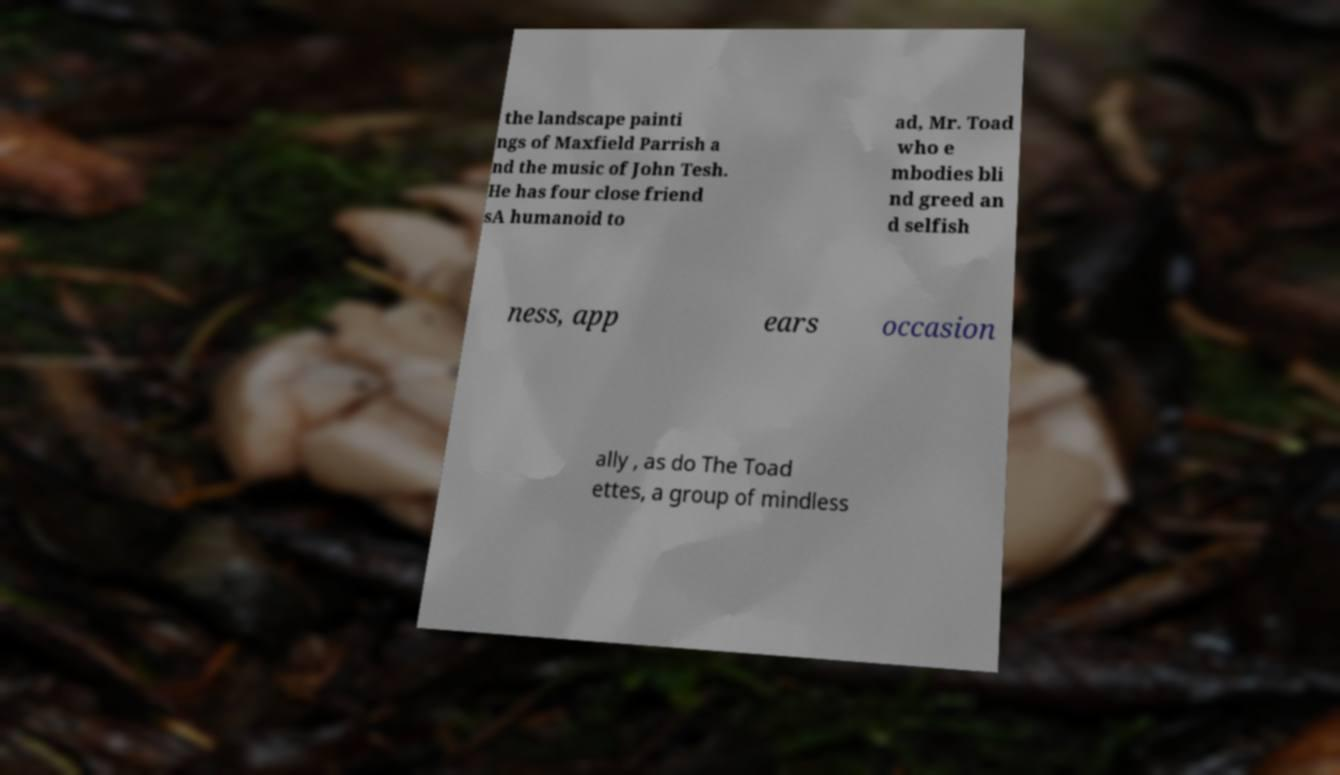I need the written content from this picture converted into text. Can you do that? the landscape painti ngs of Maxfield Parrish a nd the music of John Tesh. He has four close friend sA humanoid to ad, Mr. Toad who e mbodies bli nd greed an d selfish ness, app ears occasion ally , as do The Toad ettes, a group of mindless 